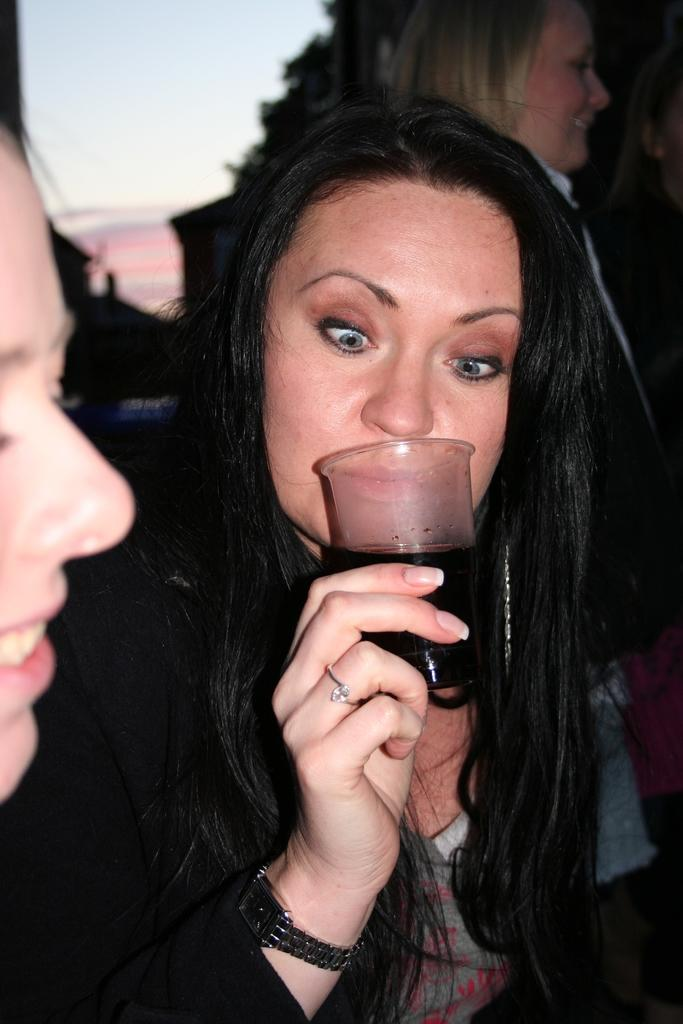Who is the main subject in the image? There is a woman in the image. What is the woman holding in the image? The woman is holding a glass with liquid in it. Can you describe the background of the image? There are clouds and trees visible in the background of the image, along with persons. Where is the person's face located in the image? The person's face is visible on the left side of the image. What type of pencil is the woman using to read in the image? There is no pencil or reading activity present in the image. 